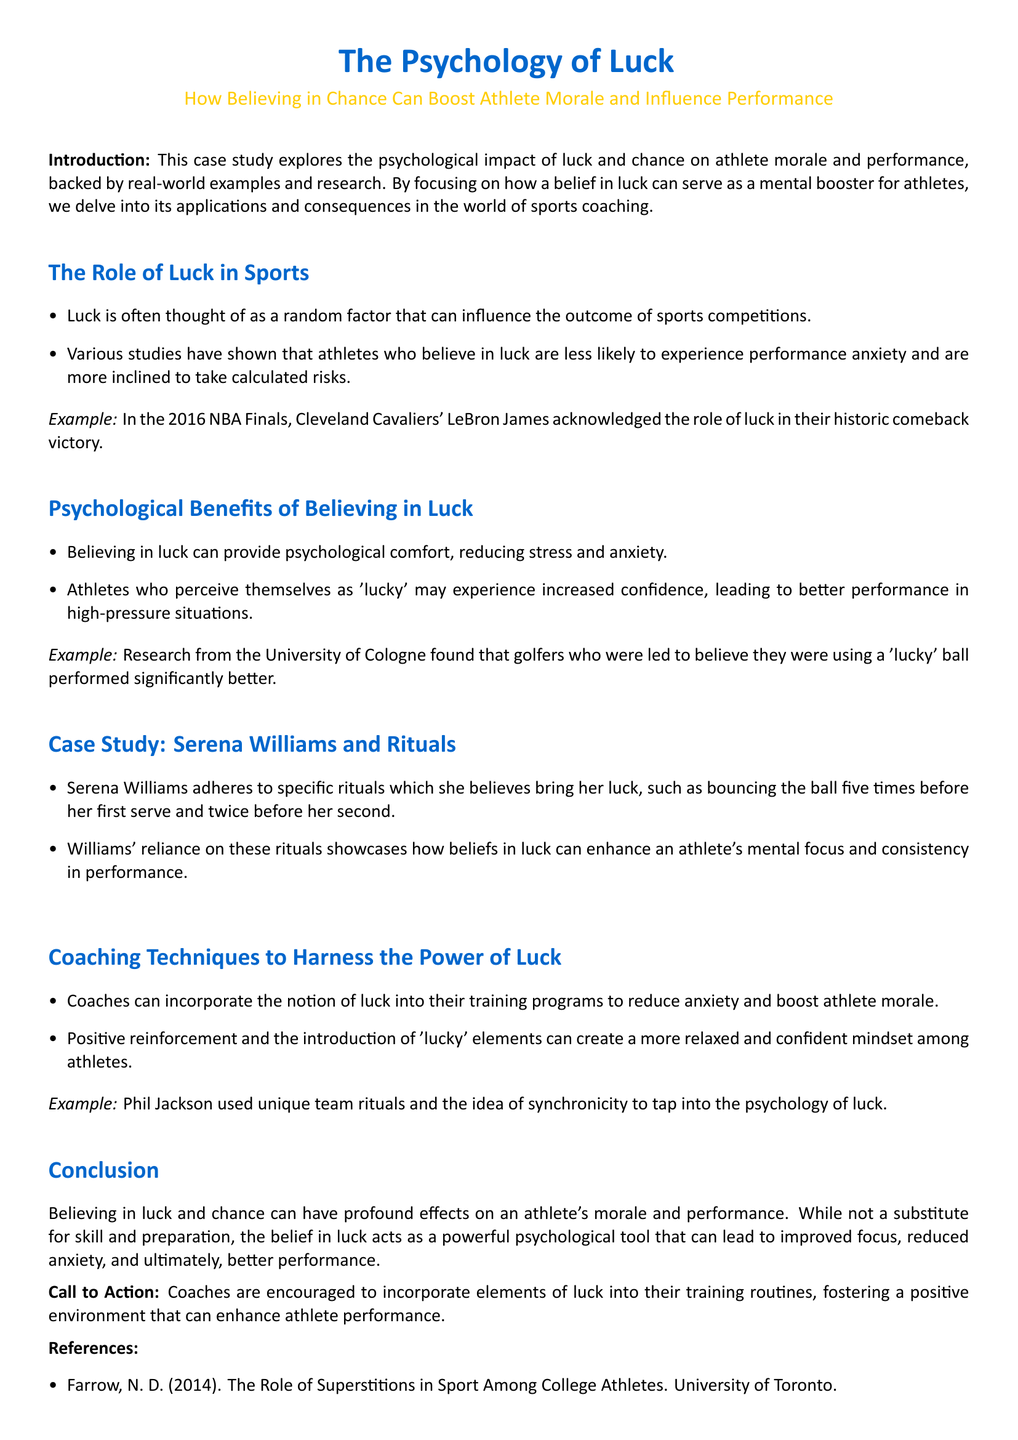What year was the NBA Finals mentioned? The NBA Finals mentioned, where the Cavaliers' comeback victory happened, was in 2016.
Answer: 2016 What specific ritual does Serena Williams perform before serving? The document states that Serena Williams bounces the ball five times before her first serve and twice before her second.
Answer: Bouncing the ball five times What psychological effect does believing in luck have on athletes? The belief in luck can provide psychological comfort, reducing stress and anxiety, as mentioned in the document.
Answer: Reducing stress and anxiety Which university conducted research on golfers' performance related to luck? The research mentioned regarding golfers and lucky balls was conducted by the University of Cologne.
Answer: University of Cologne What coaching technique is suggested to harness the power of luck? The document suggests positive reinforcement and the introduction of 'lucky' elements as coaching techniques.
Answer: Positive reinforcement Which coach used team rituals to tap into the psychology of luck? The case study mentions Phil Jackson as the coach who used unique team rituals.
Answer: Phil Jackson What is the primary theme of the conclusion? The conclusion emphasizes the profound effect of believing in luck on athlete performance and morale.
Answer: Believing in luck What can be classified as a psychological tool according to the conclusion? The belief in luck and chance is referred to as a psychological tool in the conclusion.
Answer: Psychological tool 